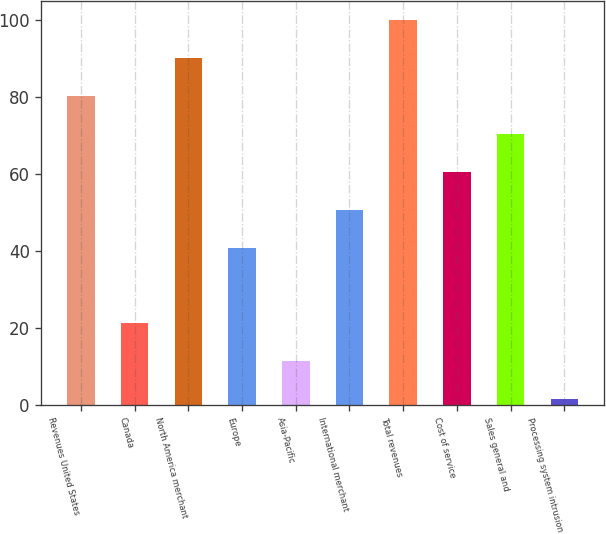Convert chart. <chart><loc_0><loc_0><loc_500><loc_500><bar_chart><fcel>Revenues United States<fcel>Canada<fcel>North America merchant<fcel>Europe<fcel>Asia-Pacific<fcel>International merchant<fcel>Total revenues<fcel>Cost of service<fcel>Sales general and<fcel>Processing system intrusion<nl><fcel>80.3<fcel>21.2<fcel>90.15<fcel>40.9<fcel>11.35<fcel>50.75<fcel>100<fcel>60.6<fcel>70.45<fcel>1.5<nl></chart> 